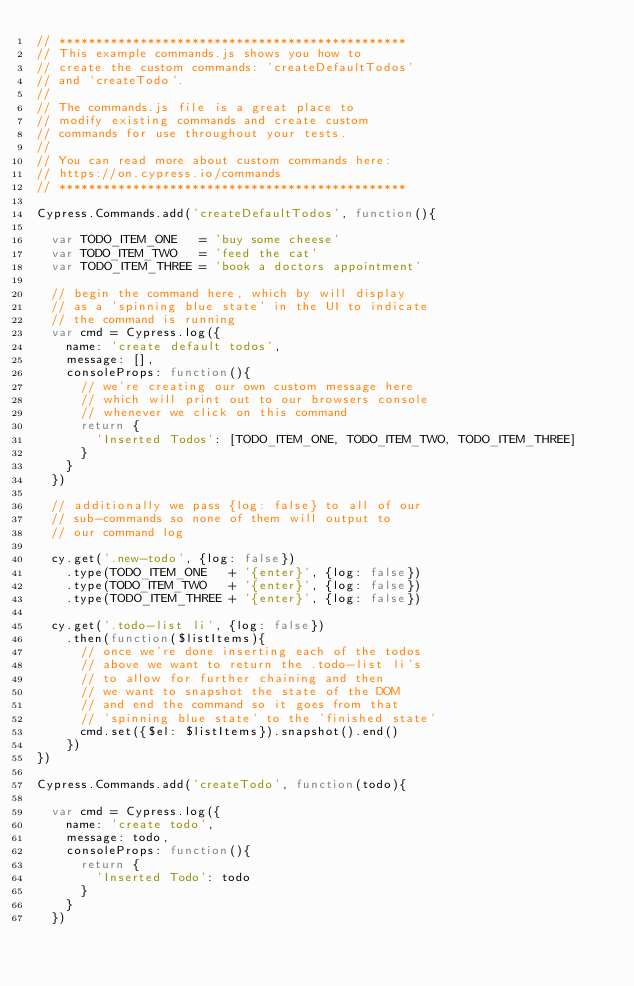<code> <loc_0><loc_0><loc_500><loc_500><_JavaScript_>// ***********************************************
// This example commands.js shows you how to
// create the custom commands: 'createDefaultTodos'
// and 'createTodo'.
//
// The commands.js file is a great place to
// modify existing commands and create custom
// commands for use throughout your tests.
//
// You can read more about custom commands here:
// https://on.cypress.io/commands
// ***********************************************

Cypress.Commands.add('createDefaultTodos', function(){

  var TODO_ITEM_ONE   = 'buy some cheese'
  var TODO_ITEM_TWO   = 'feed the cat'
  var TODO_ITEM_THREE = 'book a doctors appointment'

  // begin the command here, which by will display
  // as a 'spinning blue state' in the UI to indicate
  // the command is running
  var cmd = Cypress.log({
    name: 'create default todos',
    message: [],
    consoleProps: function(){
      // we're creating our own custom message here
      // which will print out to our browsers console
      // whenever we click on this command
      return {
        'Inserted Todos': [TODO_ITEM_ONE, TODO_ITEM_TWO, TODO_ITEM_THREE]
      }
    }
  })

  // additionally we pass {log: false} to all of our
  // sub-commands so none of them will output to
  // our command log

  cy.get('.new-todo', {log: false})
    .type(TODO_ITEM_ONE   + '{enter}', {log: false})
    .type(TODO_ITEM_TWO   + '{enter}', {log: false})
    .type(TODO_ITEM_THREE + '{enter}', {log: false})

  cy.get('.todo-list li', {log: false})
    .then(function($listItems){
      // once we're done inserting each of the todos
      // above we want to return the .todo-list li's
      // to allow for further chaining and then
      // we want to snapshot the state of the DOM
      // and end the command so it goes from that
      // 'spinning blue state' to the 'finished state'
      cmd.set({$el: $listItems}).snapshot().end()
    })
})

Cypress.Commands.add('createTodo', function(todo){

  var cmd = Cypress.log({
    name: 'create todo',
    message: todo,
    consoleProps: function(){
      return {
        'Inserted Todo': todo
      }
    }
  })
</code> 